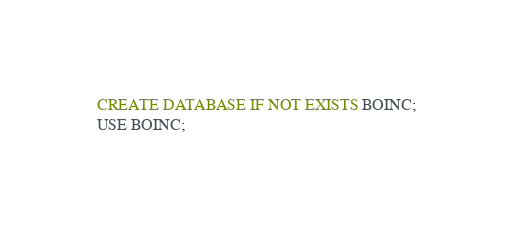<code> <loc_0><loc_0><loc_500><loc_500><_SQL_>CREATE DATABASE IF NOT EXISTS BOINC;
USE BOINC;</code> 